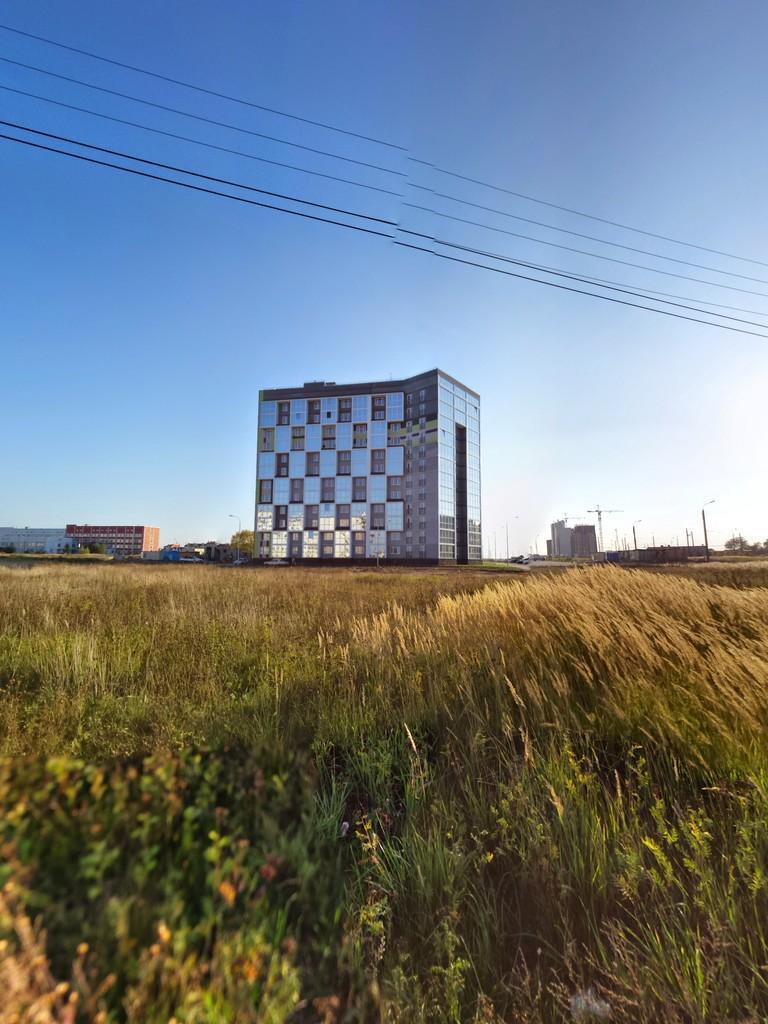Please provide a concise description of this image. In the foreground of the picture there are plants and grass. In the center of the picture there are buildings, poles and trees. At the top there are cables. Sky is clear and it is sunny. 